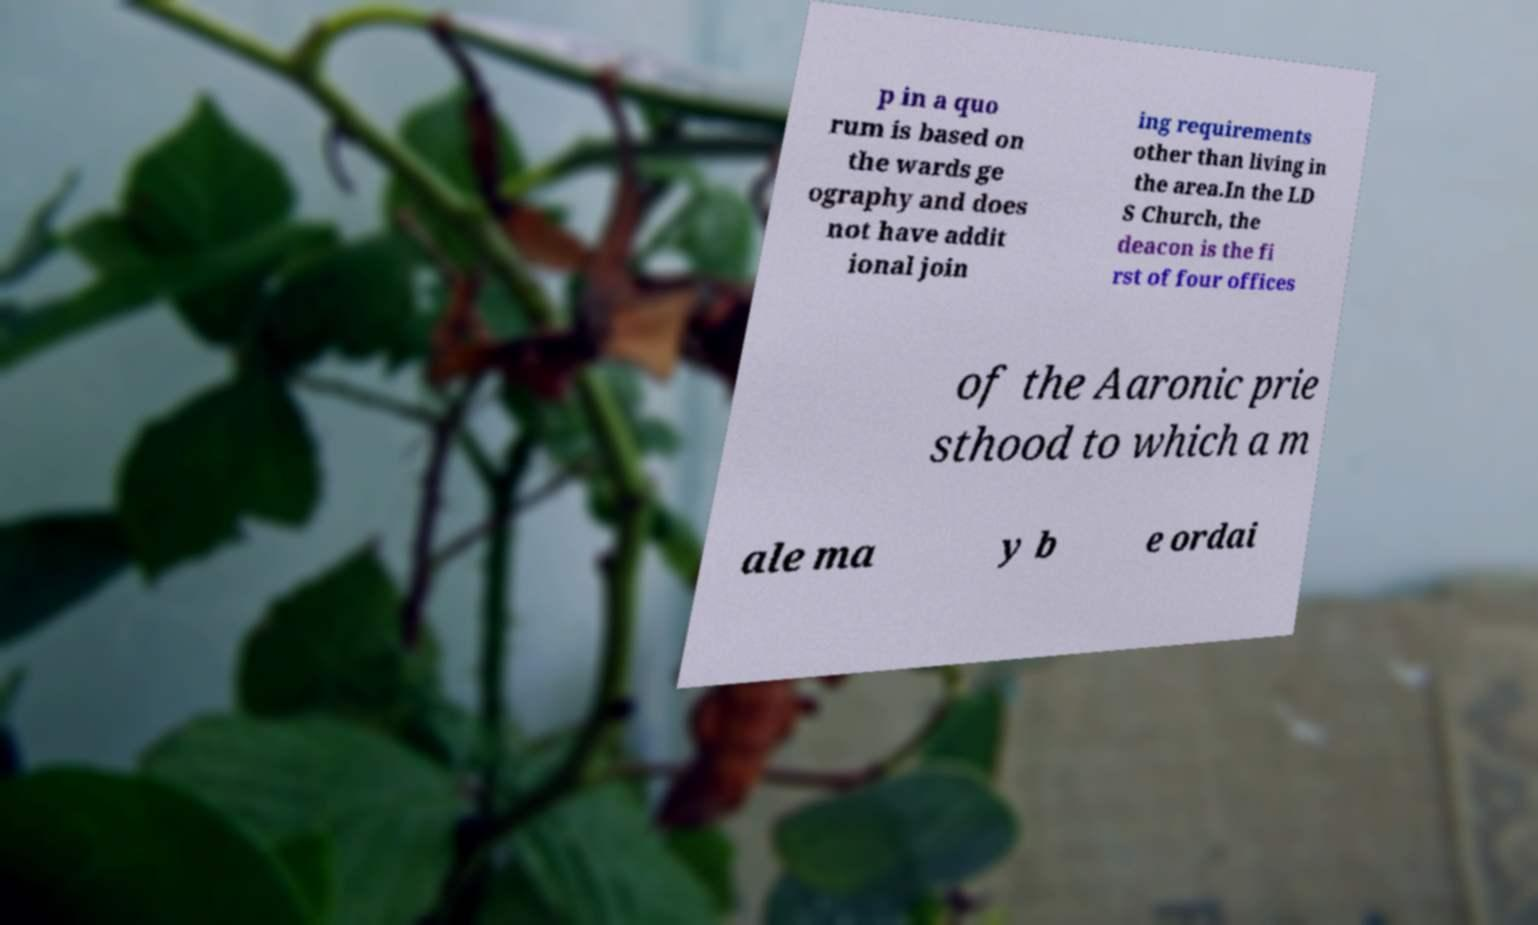What messages or text are displayed in this image? I need them in a readable, typed format. p in a quo rum is based on the wards ge ography and does not have addit ional join ing requirements other than living in the area.In the LD S Church, the deacon is the fi rst of four offices of the Aaronic prie sthood to which a m ale ma y b e ordai 